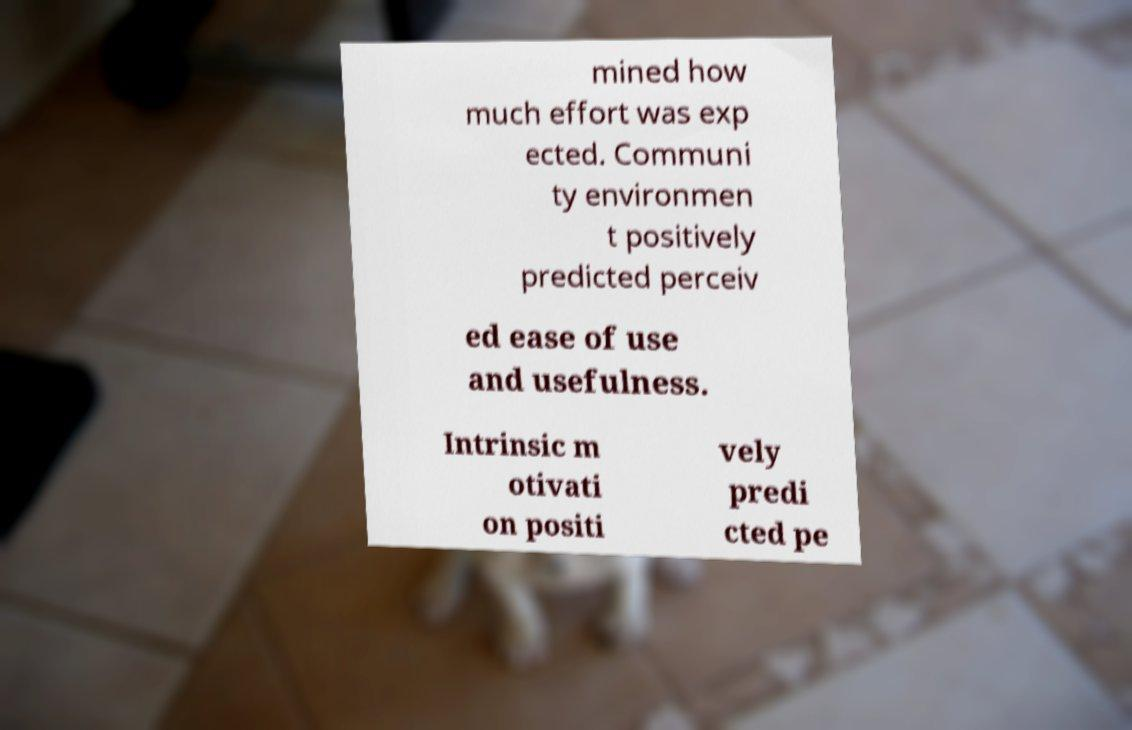Can you accurately transcribe the text from the provided image for me? mined how much effort was exp ected. Communi ty environmen t positively predicted perceiv ed ease of use and usefulness. Intrinsic m otivati on positi vely predi cted pe 